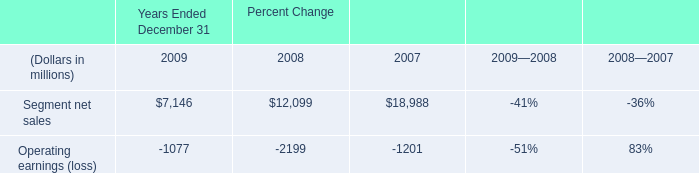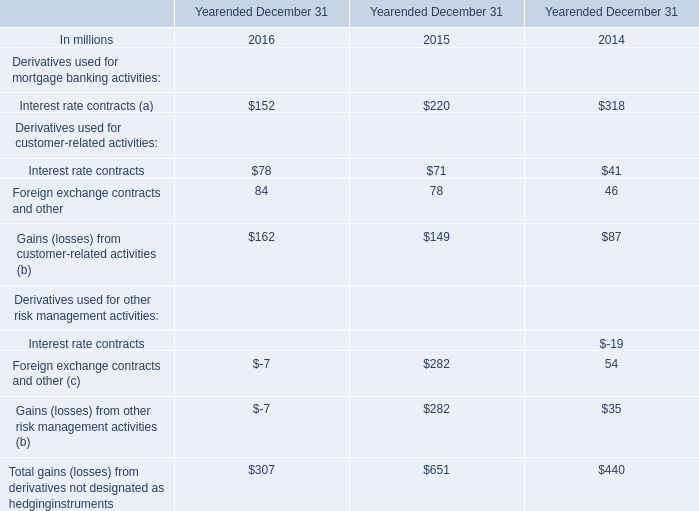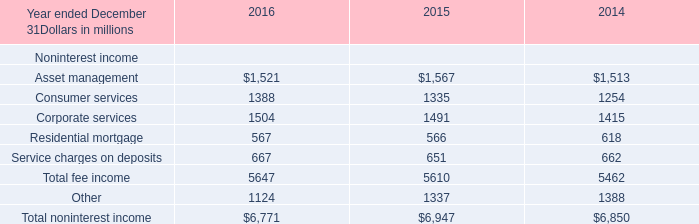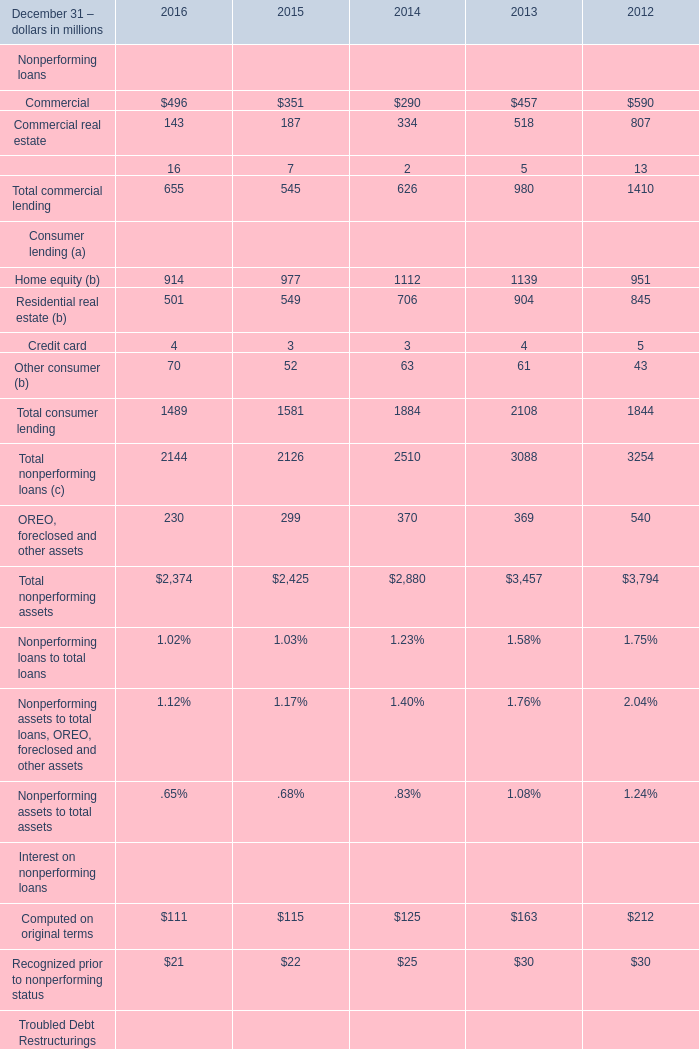In the year with the most Home equity (b), what is the growth rate of Residential real estate (b)? (in %) 
Computations: ((904 - 845) / 845)
Answer: 0.06982. 